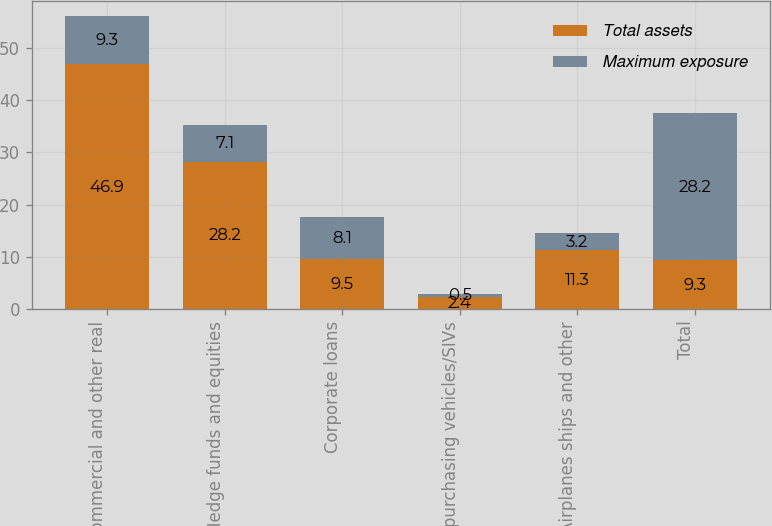Convert chart. <chart><loc_0><loc_0><loc_500><loc_500><stacked_bar_chart><ecel><fcel>Commercial and other real<fcel>Hedge funds and equities<fcel>Corporate loans<fcel>Asset purchasing vehicles/SIVs<fcel>Airplanes ships and other<fcel>Total<nl><fcel>Total assets<fcel>46.9<fcel>28.2<fcel>9.5<fcel>2.4<fcel>11.3<fcel>9.3<nl><fcel>Maximum exposure<fcel>9.3<fcel>7.1<fcel>8.1<fcel>0.5<fcel>3.2<fcel>28.2<nl></chart> 